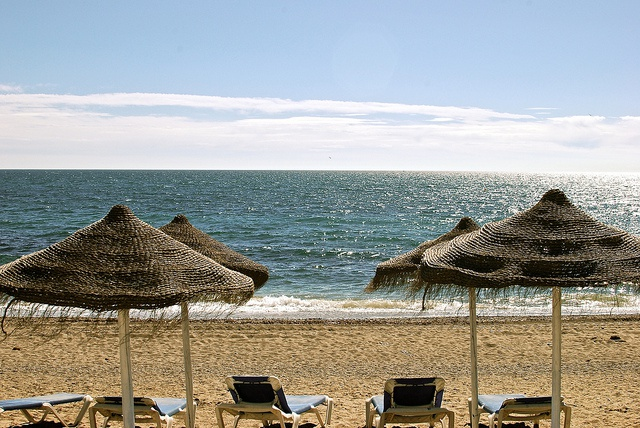Describe the objects in this image and their specific colors. I can see umbrella in lightblue, black, olive, and gray tones, umbrella in lightblue, black, and gray tones, umbrella in lightblue, black, olive, and gray tones, chair in lightblue, black, olive, maroon, and tan tones, and chair in lightblue, black, olive, lightgray, and tan tones in this image. 